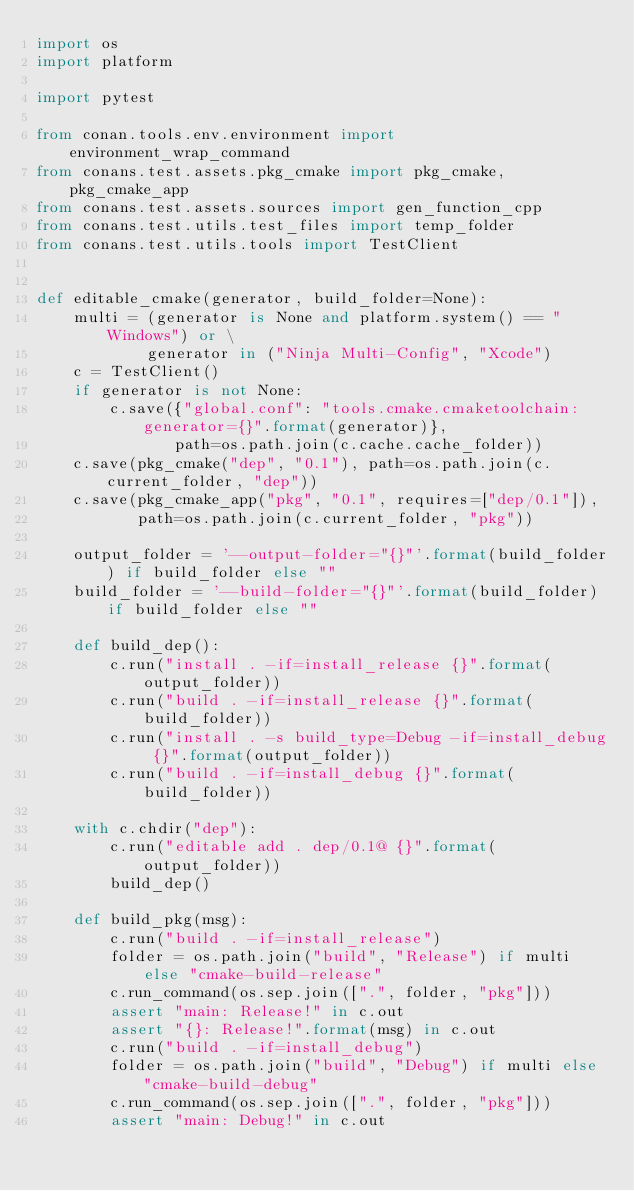<code> <loc_0><loc_0><loc_500><loc_500><_Python_>import os
import platform

import pytest

from conan.tools.env.environment import environment_wrap_command
from conans.test.assets.pkg_cmake import pkg_cmake, pkg_cmake_app
from conans.test.assets.sources import gen_function_cpp
from conans.test.utils.test_files import temp_folder
from conans.test.utils.tools import TestClient


def editable_cmake(generator, build_folder=None):
    multi = (generator is None and platform.system() == "Windows") or \
            generator in ("Ninja Multi-Config", "Xcode")
    c = TestClient()
    if generator is not None:
        c.save({"global.conf": "tools.cmake.cmaketoolchain:generator={}".format(generator)},
               path=os.path.join(c.cache.cache_folder))
    c.save(pkg_cmake("dep", "0.1"), path=os.path.join(c.current_folder, "dep"))
    c.save(pkg_cmake_app("pkg", "0.1", requires=["dep/0.1"]),
           path=os.path.join(c.current_folder, "pkg"))

    output_folder = '--output-folder="{}"'.format(build_folder) if build_folder else ""
    build_folder = '--build-folder="{}"'.format(build_folder) if build_folder else ""

    def build_dep():
        c.run("install . -if=install_release {}".format(output_folder))
        c.run("build . -if=install_release {}".format(build_folder))
        c.run("install . -s build_type=Debug -if=install_debug {}".format(output_folder))
        c.run("build . -if=install_debug {}".format(build_folder))

    with c.chdir("dep"):
        c.run("editable add . dep/0.1@ {}".format(output_folder))
        build_dep()

    def build_pkg(msg):
        c.run("build . -if=install_release")
        folder = os.path.join("build", "Release") if multi else "cmake-build-release"
        c.run_command(os.sep.join([".", folder, "pkg"]))
        assert "main: Release!" in c.out
        assert "{}: Release!".format(msg) in c.out
        c.run("build . -if=install_debug")
        folder = os.path.join("build", "Debug") if multi else "cmake-build-debug"
        c.run_command(os.sep.join([".", folder, "pkg"]))
        assert "main: Debug!" in c.out</code> 